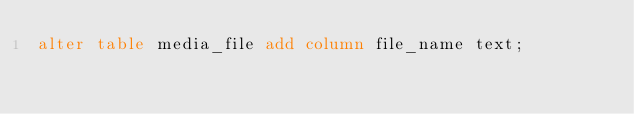<code> <loc_0><loc_0><loc_500><loc_500><_SQL_>alter table media_file add column file_name text;</code> 